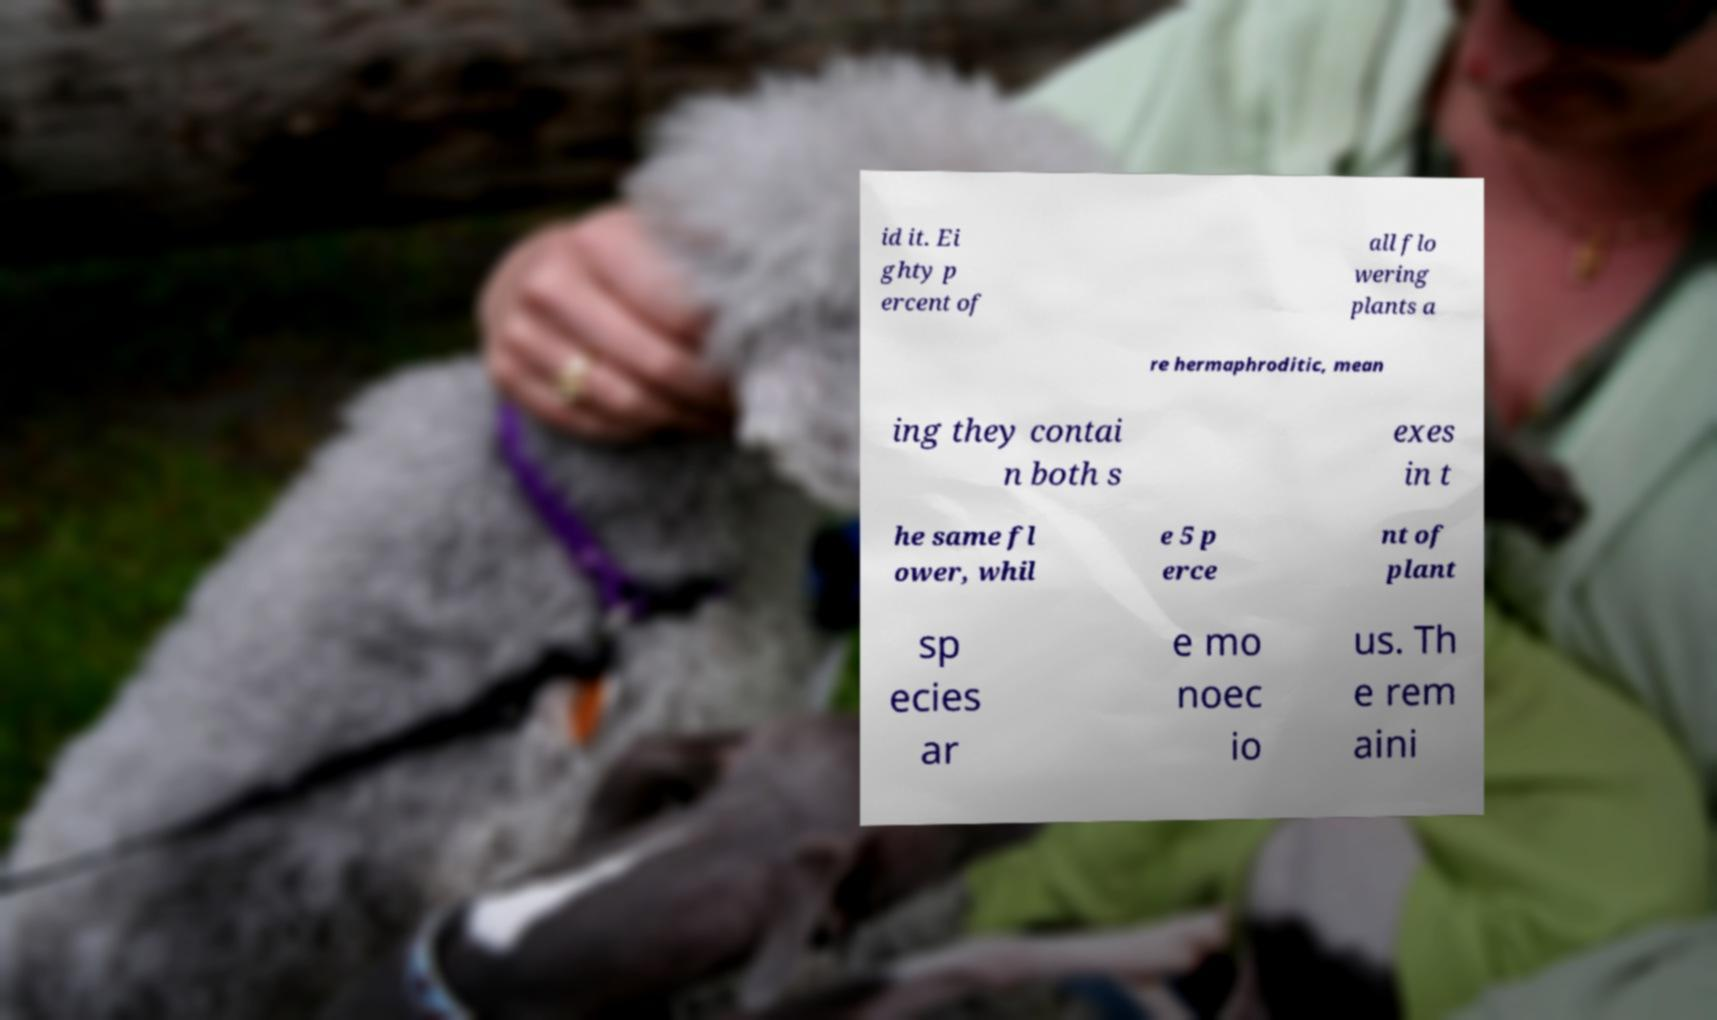Can you read and provide the text displayed in the image?This photo seems to have some interesting text. Can you extract and type it out for me? id it. Ei ghty p ercent of all flo wering plants a re hermaphroditic, mean ing they contai n both s exes in t he same fl ower, whil e 5 p erce nt of plant sp ecies ar e mo noec io us. Th e rem aini 